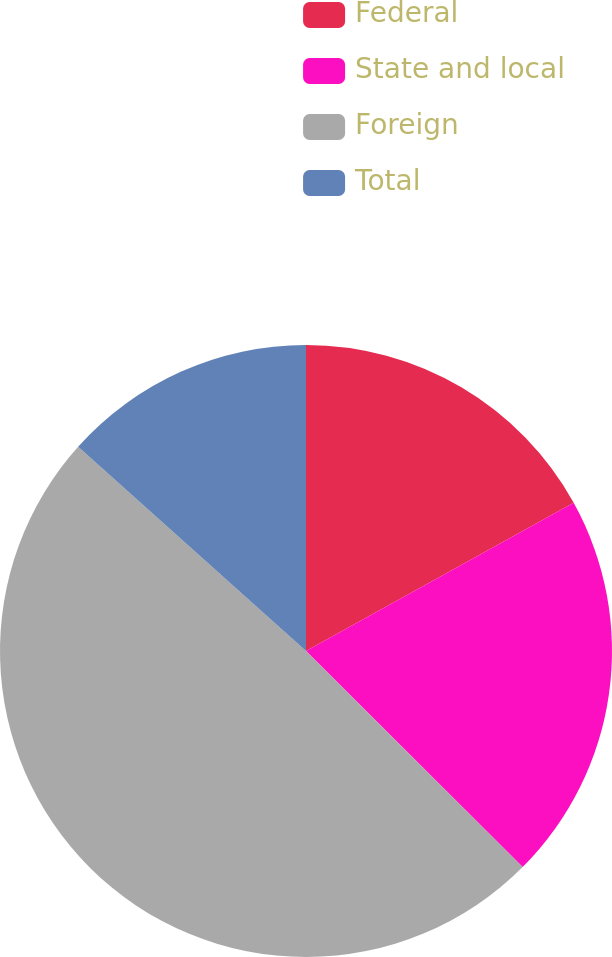<chart> <loc_0><loc_0><loc_500><loc_500><pie_chart><fcel>Federal<fcel>State and local<fcel>Foreign<fcel>Total<nl><fcel>16.95%<fcel>20.53%<fcel>49.15%<fcel>13.37%<nl></chart> 